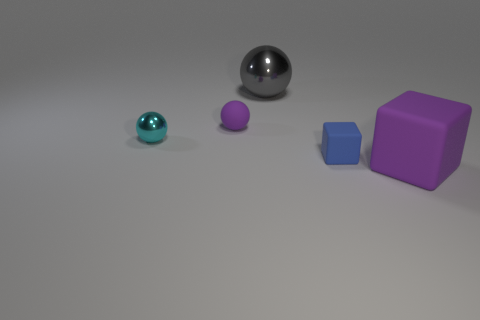What number of objects are metal objects that are behind the cyan sphere or small cyan metal spheres?
Your answer should be very brief. 2. Is the small shiny ball the same color as the small rubber block?
Your response must be concise. No. What size is the purple object behind the large purple thing?
Provide a succinct answer. Small. Is there a rubber thing of the same size as the gray sphere?
Ensure brevity in your answer.  Yes. There is a purple object to the right of the blue rubber block; is its size the same as the rubber sphere?
Provide a short and direct response. No. How big is the blue matte object?
Your answer should be very brief. Small. The small matte object that is behind the rubber cube that is to the left of the purple object right of the small purple sphere is what color?
Ensure brevity in your answer.  Purple. There is a small block that is to the right of the cyan metal thing; is its color the same as the small shiny ball?
Provide a short and direct response. No. How many large things are to the right of the gray object and behind the purple rubber cube?
Ensure brevity in your answer.  0. The purple rubber object that is the same shape as the small cyan thing is what size?
Keep it short and to the point. Small. 